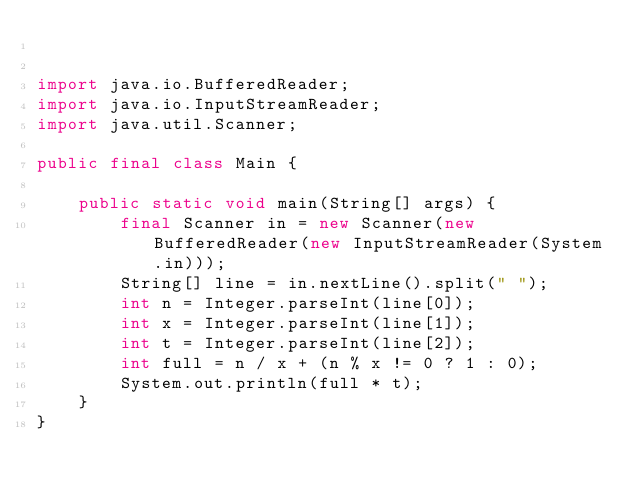<code> <loc_0><loc_0><loc_500><loc_500><_Java_>

import java.io.BufferedReader;
import java.io.InputStreamReader;
import java.util.Scanner;

public final class Main {

    public static void main(String[] args) {
        final Scanner in = new Scanner(new BufferedReader(new InputStreamReader(System.in)));
        String[] line = in.nextLine().split(" ");
        int n = Integer.parseInt(line[0]);
        int x = Integer.parseInt(line[1]);
        int t = Integer.parseInt(line[2]);
        int full = n / x + (n % x != 0 ? 1 : 0);
        System.out.println(full * t);
    }
}
</code> 